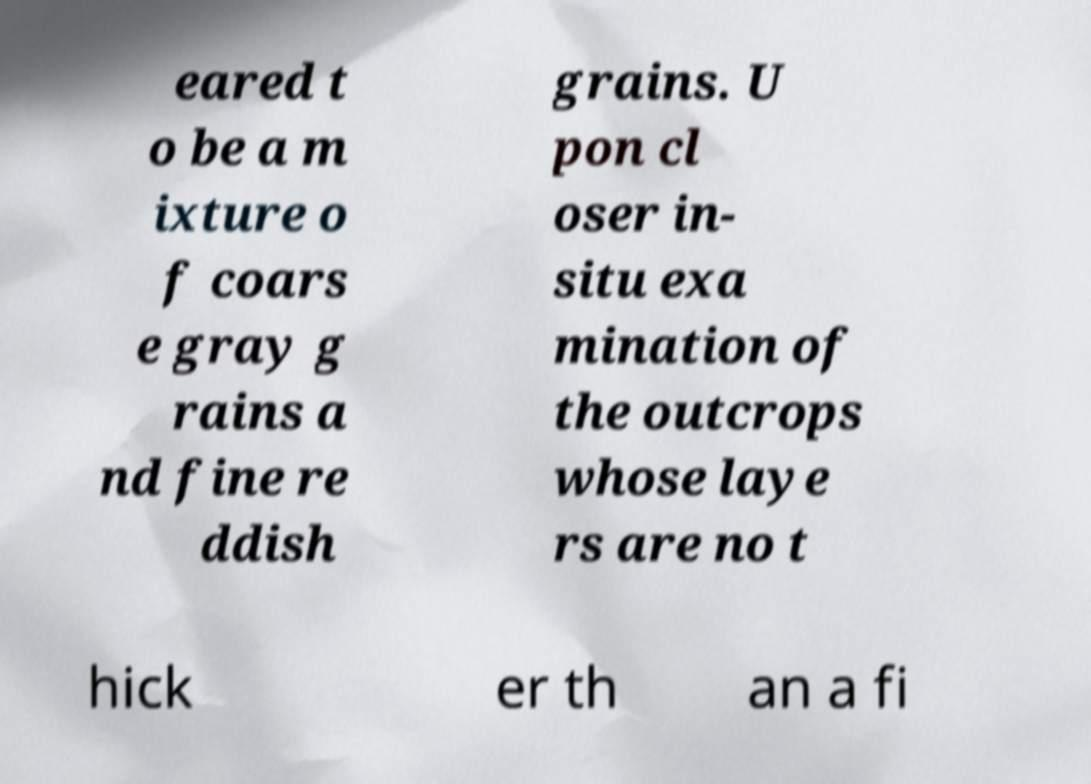Can you read and provide the text displayed in the image?This photo seems to have some interesting text. Can you extract and type it out for me? eared t o be a m ixture o f coars e gray g rains a nd fine re ddish grains. U pon cl oser in- situ exa mination of the outcrops whose laye rs are no t hick er th an a fi 